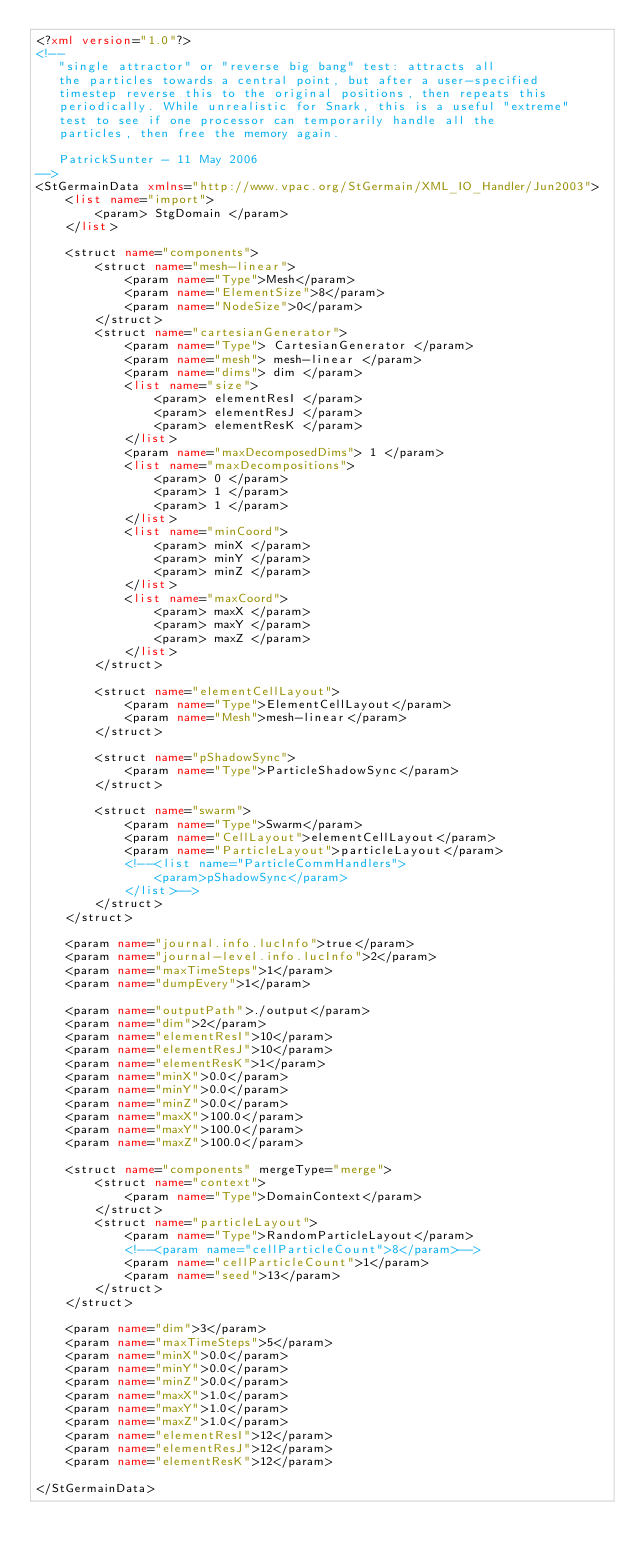<code> <loc_0><loc_0><loc_500><loc_500><_XML_><?xml version="1.0"?>
<!--
   "single attractor" or "reverse big bang" test: attracts all
   the particles towards a central point, but after a user-specified
   timestep reverse this to the original positions, then repeats this
   periodically. While unrealistic for Snark, this is a useful "extreme"
   test to see if one processor can temporarily handle all the
   particles, then free the memory again.

   PatrickSunter - 11 May 2006
-->
<StGermainData xmlns="http://www.vpac.org/StGermain/XML_IO_Handler/Jun2003">
	<list name="import">
		<param> StgDomain </param>
	</list>

	<struct name="components">
		<struct name="mesh-linear">
			<param name="Type">Mesh</param>
			<param name="ElementSize">8</param>
			<param name="NodeSize">0</param>
		</struct>
		<struct name="cartesianGenerator">
			<param name="Type"> CartesianGenerator </param>
			<param name="mesh"> mesh-linear </param>
			<param name="dims"> dim </param>
			<list name="size">
				<param> elementResI </param>
				<param> elementResJ </param>
				<param> elementResK </param>
			</list>
			<param name="maxDecomposedDims"> 1 </param>
			<list name="maxDecompositions">
				<param> 0 </param>
				<param> 1 </param>
				<param> 1 </param>
			</list>
			<list name="minCoord">
				<param> minX </param>
				<param> minY </param>
				<param> minZ </param>
			</list>
			<list name="maxCoord">
				<param> maxX </param>
				<param> maxY </param>
				<param> maxZ </param>
			</list>
		</struct>
 
		<struct name="elementCellLayout"> 
			<param name="Type">ElementCellLayout</param>
			<param name="Mesh">mesh-linear</param>
		</struct>

		<struct name="pShadowSync"> 
			<param name="Type">ParticleShadowSync</param>
		</struct>
		
		<struct name="swarm">
			<param name="Type">Swarm</param>
			<param name="CellLayout">elementCellLayout</param>
			<param name="ParticleLayout">particleLayout</param>
			<!--<list name="ParticleCommHandlers">
				<param>pShadowSync</param>
			</list>-->			
		</struct>
	</struct>
 
	<param name="journal.info.lucInfo">true</param>
	<param name="journal-level.info.lucInfo">2</param>
	<param name="maxTimeSteps">1</param> 
	<param name="dumpEvery">1</param>

	<param name="outputPath">./output</param> 
	<param name="dim">2</param>
	<param name="elementResI">10</param>
	<param name="elementResJ">10</param> 
	<param name="elementResK">1</param> 
	<param name="minX">0.0</param> 
	<param name="minY">0.0</param> 
	<param name="minZ">0.0</param>
	<param name="maxX">100.0</param> 
	<param name="maxY">100.0</param>
	<param name="maxZ">100.0</param>

	<struct name="components" mergeType="merge">
		<struct name="context">
			<param name="Type">DomainContext</param>
		</struct>
		<struct name="particleLayout">
			<param name="Type">RandomParticleLayout</param>
			<!--<param name="cellParticleCount">8</param>-->
			<param name="cellParticleCount">1</param>
			<param name="seed">13</param>
		</struct>
	</struct>

	<param name="dim">3</param>
	<param name="maxTimeSteps">5</param> 
	<param name="minX">0.0</param> 
	<param name="minY">0.0</param> 
	<param name="minZ">0.0</param>
	<param name="maxX">1.0</param> 
	<param name="maxY">1.0</param>
	<param name="maxZ">1.0</param>
	<param name="elementResI">12</param>
	<param name="elementResJ">12</param>
	<param name="elementResK">12</param>

</StGermainData>
</code> 